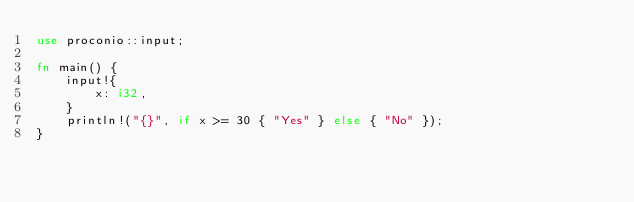<code> <loc_0><loc_0><loc_500><loc_500><_Rust_>use proconio::input;

fn main() {
    input!{
        x: i32,
    }
    println!("{}", if x >= 30 { "Yes" } else { "No" });
}
</code> 